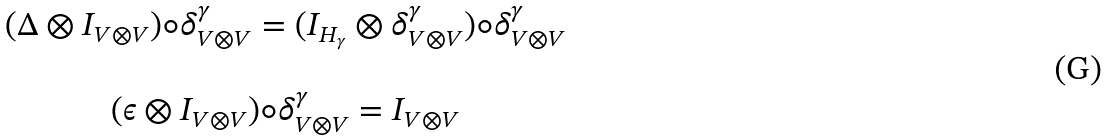Convert formula to latex. <formula><loc_0><loc_0><loc_500><loc_500>\begin{array} { c } ( \Delta \otimes I _ { V \otimes V } ) \circ \delta _ { V \otimes V } ^ { \gamma } = ( I _ { H _ { \gamma } } \otimes \delta _ { V \otimes V } ^ { \gamma } ) \circ \delta _ { V \otimes V } ^ { \gamma } \\ \\ ( \epsilon \otimes I _ { V \otimes V } ) \circ \delta _ { V \otimes V } ^ { \gamma } = I _ { V \otimes V } \end{array}</formula> 